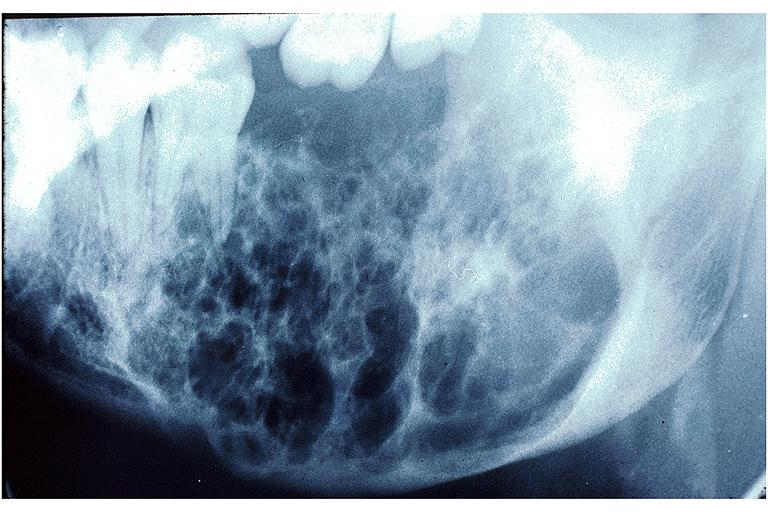what is present?
Answer the question using a single word or phrase. Oral 